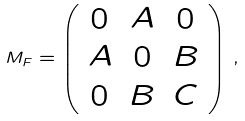<formula> <loc_0><loc_0><loc_500><loc_500>M _ { F } = \left ( \begin{array} { c c c } 0 & A & 0 \\ A & 0 & B \\ 0 & B & C \end{array} \right ) \, ,</formula> 